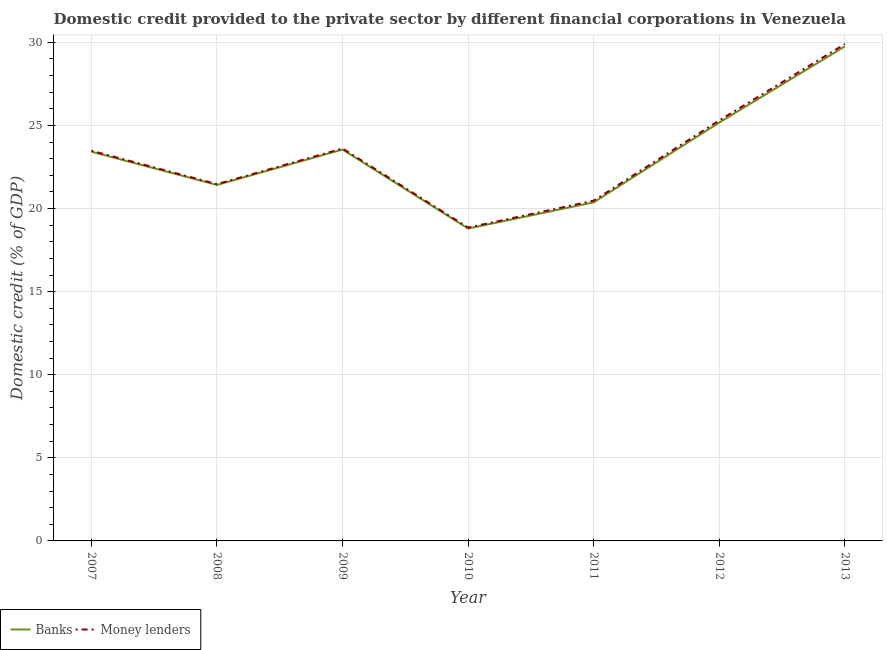Does the line corresponding to domestic credit provided by banks intersect with the line corresponding to domestic credit provided by money lenders?
Offer a very short reply. No. Is the number of lines equal to the number of legend labels?
Provide a short and direct response. Yes. What is the domestic credit provided by money lenders in 2013?
Make the answer very short. 29.9. Across all years, what is the maximum domestic credit provided by banks?
Your answer should be compact. 29.76. Across all years, what is the minimum domestic credit provided by money lenders?
Give a very brief answer. 18.85. In which year was the domestic credit provided by banks minimum?
Provide a short and direct response. 2010. What is the total domestic credit provided by banks in the graph?
Your response must be concise. 162.49. What is the difference between the domestic credit provided by money lenders in 2010 and that in 2012?
Make the answer very short. -6.45. What is the difference between the domestic credit provided by money lenders in 2009 and the domestic credit provided by banks in 2013?
Make the answer very short. -6.14. What is the average domestic credit provided by money lenders per year?
Ensure brevity in your answer.  23.3. In the year 2009, what is the difference between the domestic credit provided by banks and domestic credit provided by money lenders?
Keep it short and to the point. -0.06. What is the ratio of the domestic credit provided by money lenders in 2007 to that in 2012?
Ensure brevity in your answer.  0.93. Is the difference between the domestic credit provided by money lenders in 2011 and 2013 greater than the difference between the domestic credit provided by banks in 2011 and 2013?
Provide a succinct answer. No. What is the difference between the highest and the second highest domestic credit provided by banks?
Ensure brevity in your answer.  4.58. What is the difference between the highest and the lowest domestic credit provided by money lenders?
Ensure brevity in your answer.  11.04. In how many years, is the domestic credit provided by banks greater than the average domestic credit provided by banks taken over all years?
Ensure brevity in your answer.  4. Is the domestic credit provided by banks strictly less than the domestic credit provided by money lenders over the years?
Provide a succinct answer. Yes. What is the difference between two consecutive major ticks on the Y-axis?
Your answer should be very brief. 5. How are the legend labels stacked?
Keep it short and to the point. Horizontal. What is the title of the graph?
Offer a terse response. Domestic credit provided to the private sector by different financial corporations in Venezuela. Does "Forest" appear as one of the legend labels in the graph?
Offer a terse response. No. What is the label or title of the Y-axis?
Offer a very short reply. Domestic credit (% of GDP). What is the Domestic credit (% of GDP) of Banks in 2007?
Your answer should be compact. 23.42. What is the Domestic credit (% of GDP) in Money lenders in 2007?
Keep it short and to the point. 23.48. What is the Domestic credit (% of GDP) in Banks in 2008?
Ensure brevity in your answer.  21.42. What is the Domestic credit (% of GDP) of Money lenders in 2008?
Keep it short and to the point. 21.47. What is the Domestic credit (% of GDP) in Banks in 2009?
Make the answer very short. 23.55. What is the Domestic credit (% of GDP) of Money lenders in 2009?
Keep it short and to the point. 23.61. What is the Domestic credit (% of GDP) in Banks in 2010?
Ensure brevity in your answer.  18.8. What is the Domestic credit (% of GDP) of Money lenders in 2010?
Your answer should be very brief. 18.85. What is the Domestic credit (% of GDP) in Banks in 2011?
Provide a succinct answer. 20.37. What is the Domestic credit (% of GDP) in Money lenders in 2011?
Provide a succinct answer. 20.47. What is the Domestic credit (% of GDP) of Banks in 2012?
Offer a terse response. 25.18. What is the Domestic credit (% of GDP) in Money lenders in 2012?
Give a very brief answer. 25.3. What is the Domestic credit (% of GDP) of Banks in 2013?
Provide a succinct answer. 29.76. What is the Domestic credit (% of GDP) of Money lenders in 2013?
Keep it short and to the point. 29.9. Across all years, what is the maximum Domestic credit (% of GDP) of Banks?
Ensure brevity in your answer.  29.76. Across all years, what is the maximum Domestic credit (% of GDP) in Money lenders?
Keep it short and to the point. 29.9. Across all years, what is the minimum Domestic credit (% of GDP) of Banks?
Make the answer very short. 18.8. Across all years, what is the minimum Domestic credit (% of GDP) in Money lenders?
Provide a short and direct response. 18.85. What is the total Domestic credit (% of GDP) in Banks in the graph?
Offer a terse response. 162.49. What is the total Domestic credit (% of GDP) of Money lenders in the graph?
Provide a succinct answer. 163.09. What is the difference between the Domestic credit (% of GDP) in Banks in 2007 and that in 2008?
Make the answer very short. 2. What is the difference between the Domestic credit (% of GDP) of Money lenders in 2007 and that in 2008?
Your answer should be compact. 2.01. What is the difference between the Domestic credit (% of GDP) of Banks in 2007 and that in 2009?
Offer a terse response. -0.13. What is the difference between the Domestic credit (% of GDP) in Money lenders in 2007 and that in 2009?
Offer a terse response. -0.13. What is the difference between the Domestic credit (% of GDP) of Banks in 2007 and that in 2010?
Provide a short and direct response. 4.62. What is the difference between the Domestic credit (% of GDP) of Money lenders in 2007 and that in 2010?
Make the answer very short. 4.63. What is the difference between the Domestic credit (% of GDP) in Banks in 2007 and that in 2011?
Your answer should be compact. 3.05. What is the difference between the Domestic credit (% of GDP) of Money lenders in 2007 and that in 2011?
Keep it short and to the point. 3.01. What is the difference between the Domestic credit (% of GDP) in Banks in 2007 and that in 2012?
Offer a terse response. -1.76. What is the difference between the Domestic credit (% of GDP) of Money lenders in 2007 and that in 2012?
Provide a short and direct response. -1.82. What is the difference between the Domestic credit (% of GDP) of Banks in 2007 and that in 2013?
Keep it short and to the point. -6.34. What is the difference between the Domestic credit (% of GDP) in Money lenders in 2007 and that in 2013?
Provide a succinct answer. -6.42. What is the difference between the Domestic credit (% of GDP) in Banks in 2008 and that in 2009?
Offer a very short reply. -2.13. What is the difference between the Domestic credit (% of GDP) of Money lenders in 2008 and that in 2009?
Offer a very short reply. -2.14. What is the difference between the Domestic credit (% of GDP) of Banks in 2008 and that in 2010?
Give a very brief answer. 2.62. What is the difference between the Domestic credit (% of GDP) in Money lenders in 2008 and that in 2010?
Give a very brief answer. 2.62. What is the difference between the Domestic credit (% of GDP) in Banks in 2008 and that in 2011?
Provide a succinct answer. 1.05. What is the difference between the Domestic credit (% of GDP) in Money lenders in 2008 and that in 2011?
Keep it short and to the point. 1. What is the difference between the Domestic credit (% of GDP) in Banks in 2008 and that in 2012?
Your answer should be very brief. -3.75. What is the difference between the Domestic credit (% of GDP) of Money lenders in 2008 and that in 2012?
Make the answer very short. -3.83. What is the difference between the Domestic credit (% of GDP) of Banks in 2008 and that in 2013?
Give a very brief answer. -8.33. What is the difference between the Domestic credit (% of GDP) of Money lenders in 2008 and that in 2013?
Offer a terse response. -8.43. What is the difference between the Domestic credit (% of GDP) in Banks in 2009 and that in 2010?
Your answer should be compact. 4.75. What is the difference between the Domestic credit (% of GDP) of Money lenders in 2009 and that in 2010?
Give a very brief answer. 4.76. What is the difference between the Domestic credit (% of GDP) in Banks in 2009 and that in 2011?
Offer a terse response. 3.18. What is the difference between the Domestic credit (% of GDP) of Money lenders in 2009 and that in 2011?
Make the answer very short. 3.14. What is the difference between the Domestic credit (% of GDP) of Banks in 2009 and that in 2012?
Keep it short and to the point. -1.62. What is the difference between the Domestic credit (% of GDP) in Money lenders in 2009 and that in 2012?
Make the answer very short. -1.69. What is the difference between the Domestic credit (% of GDP) of Banks in 2009 and that in 2013?
Provide a short and direct response. -6.21. What is the difference between the Domestic credit (% of GDP) of Money lenders in 2009 and that in 2013?
Offer a very short reply. -6.28. What is the difference between the Domestic credit (% of GDP) of Banks in 2010 and that in 2011?
Offer a very short reply. -1.58. What is the difference between the Domestic credit (% of GDP) of Money lenders in 2010 and that in 2011?
Give a very brief answer. -1.62. What is the difference between the Domestic credit (% of GDP) in Banks in 2010 and that in 2012?
Ensure brevity in your answer.  -6.38. What is the difference between the Domestic credit (% of GDP) of Money lenders in 2010 and that in 2012?
Your answer should be compact. -6.45. What is the difference between the Domestic credit (% of GDP) of Banks in 2010 and that in 2013?
Give a very brief answer. -10.96. What is the difference between the Domestic credit (% of GDP) of Money lenders in 2010 and that in 2013?
Provide a short and direct response. -11.04. What is the difference between the Domestic credit (% of GDP) of Banks in 2011 and that in 2012?
Provide a short and direct response. -4.8. What is the difference between the Domestic credit (% of GDP) of Money lenders in 2011 and that in 2012?
Make the answer very short. -4.83. What is the difference between the Domestic credit (% of GDP) in Banks in 2011 and that in 2013?
Ensure brevity in your answer.  -9.38. What is the difference between the Domestic credit (% of GDP) of Money lenders in 2011 and that in 2013?
Your response must be concise. -9.42. What is the difference between the Domestic credit (% of GDP) in Banks in 2012 and that in 2013?
Offer a terse response. -4.58. What is the difference between the Domestic credit (% of GDP) of Money lenders in 2012 and that in 2013?
Ensure brevity in your answer.  -4.59. What is the difference between the Domestic credit (% of GDP) in Banks in 2007 and the Domestic credit (% of GDP) in Money lenders in 2008?
Keep it short and to the point. 1.95. What is the difference between the Domestic credit (% of GDP) of Banks in 2007 and the Domestic credit (% of GDP) of Money lenders in 2009?
Give a very brief answer. -0.19. What is the difference between the Domestic credit (% of GDP) of Banks in 2007 and the Domestic credit (% of GDP) of Money lenders in 2010?
Your answer should be compact. 4.57. What is the difference between the Domestic credit (% of GDP) of Banks in 2007 and the Domestic credit (% of GDP) of Money lenders in 2011?
Your answer should be very brief. 2.95. What is the difference between the Domestic credit (% of GDP) of Banks in 2007 and the Domestic credit (% of GDP) of Money lenders in 2012?
Your response must be concise. -1.88. What is the difference between the Domestic credit (% of GDP) in Banks in 2007 and the Domestic credit (% of GDP) in Money lenders in 2013?
Keep it short and to the point. -6.48. What is the difference between the Domestic credit (% of GDP) of Banks in 2008 and the Domestic credit (% of GDP) of Money lenders in 2009?
Ensure brevity in your answer.  -2.19. What is the difference between the Domestic credit (% of GDP) of Banks in 2008 and the Domestic credit (% of GDP) of Money lenders in 2010?
Make the answer very short. 2.57. What is the difference between the Domestic credit (% of GDP) of Banks in 2008 and the Domestic credit (% of GDP) of Money lenders in 2011?
Your response must be concise. 0.95. What is the difference between the Domestic credit (% of GDP) of Banks in 2008 and the Domestic credit (% of GDP) of Money lenders in 2012?
Your response must be concise. -3.88. What is the difference between the Domestic credit (% of GDP) in Banks in 2008 and the Domestic credit (% of GDP) in Money lenders in 2013?
Keep it short and to the point. -8.47. What is the difference between the Domestic credit (% of GDP) in Banks in 2009 and the Domestic credit (% of GDP) in Money lenders in 2010?
Keep it short and to the point. 4.7. What is the difference between the Domestic credit (% of GDP) in Banks in 2009 and the Domestic credit (% of GDP) in Money lenders in 2011?
Keep it short and to the point. 3.08. What is the difference between the Domestic credit (% of GDP) in Banks in 2009 and the Domestic credit (% of GDP) in Money lenders in 2012?
Your answer should be very brief. -1.75. What is the difference between the Domestic credit (% of GDP) of Banks in 2009 and the Domestic credit (% of GDP) of Money lenders in 2013?
Your answer should be very brief. -6.35. What is the difference between the Domestic credit (% of GDP) in Banks in 2010 and the Domestic credit (% of GDP) in Money lenders in 2011?
Provide a short and direct response. -1.68. What is the difference between the Domestic credit (% of GDP) in Banks in 2010 and the Domestic credit (% of GDP) in Money lenders in 2012?
Make the answer very short. -6.51. What is the difference between the Domestic credit (% of GDP) of Banks in 2010 and the Domestic credit (% of GDP) of Money lenders in 2013?
Provide a short and direct response. -11.1. What is the difference between the Domestic credit (% of GDP) in Banks in 2011 and the Domestic credit (% of GDP) in Money lenders in 2012?
Your response must be concise. -4.93. What is the difference between the Domestic credit (% of GDP) in Banks in 2011 and the Domestic credit (% of GDP) in Money lenders in 2013?
Your answer should be very brief. -9.52. What is the difference between the Domestic credit (% of GDP) of Banks in 2012 and the Domestic credit (% of GDP) of Money lenders in 2013?
Ensure brevity in your answer.  -4.72. What is the average Domestic credit (% of GDP) in Banks per year?
Your response must be concise. 23.21. What is the average Domestic credit (% of GDP) of Money lenders per year?
Give a very brief answer. 23.3. In the year 2007, what is the difference between the Domestic credit (% of GDP) of Banks and Domestic credit (% of GDP) of Money lenders?
Offer a very short reply. -0.06. In the year 2008, what is the difference between the Domestic credit (% of GDP) of Banks and Domestic credit (% of GDP) of Money lenders?
Provide a succinct answer. -0.05. In the year 2009, what is the difference between the Domestic credit (% of GDP) of Banks and Domestic credit (% of GDP) of Money lenders?
Ensure brevity in your answer.  -0.06. In the year 2010, what is the difference between the Domestic credit (% of GDP) of Banks and Domestic credit (% of GDP) of Money lenders?
Your answer should be compact. -0.06. In the year 2011, what is the difference between the Domestic credit (% of GDP) in Banks and Domestic credit (% of GDP) in Money lenders?
Your answer should be compact. -0.1. In the year 2012, what is the difference between the Domestic credit (% of GDP) of Banks and Domestic credit (% of GDP) of Money lenders?
Offer a very short reply. -0.13. In the year 2013, what is the difference between the Domestic credit (% of GDP) in Banks and Domestic credit (% of GDP) in Money lenders?
Your answer should be very brief. -0.14. What is the ratio of the Domestic credit (% of GDP) in Banks in 2007 to that in 2008?
Your answer should be compact. 1.09. What is the ratio of the Domestic credit (% of GDP) of Money lenders in 2007 to that in 2008?
Make the answer very short. 1.09. What is the ratio of the Domestic credit (% of GDP) of Banks in 2007 to that in 2010?
Your answer should be compact. 1.25. What is the ratio of the Domestic credit (% of GDP) of Money lenders in 2007 to that in 2010?
Offer a very short reply. 1.25. What is the ratio of the Domestic credit (% of GDP) in Banks in 2007 to that in 2011?
Make the answer very short. 1.15. What is the ratio of the Domestic credit (% of GDP) in Money lenders in 2007 to that in 2011?
Your answer should be compact. 1.15. What is the ratio of the Domestic credit (% of GDP) in Banks in 2007 to that in 2012?
Give a very brief answer. 0.93. What is the ratio of the Domestic credit (% of GDP) of Money lenders in 2007 to that in 2012?
Provide a succinct answer. 0.93. What is the ratio of the Domestic credit (% of GDP) of Banks in 2007 to that in 2013?
Provide a succinct answer. 0.79. What is the ratio of the Domestic credit (% of GDP) of Money lenders in 2007 to that in 2013?
Offer a terse response. 0.79. What is the ratio of the Domestic credit (% of GDP) of Banks in 2008 to that in 2009?
Provide a short and direct response. 0.91. What is the ratio of the Domestic credit (% of GDP) in Money lenders in 2008 to that in 2009?
Ensure brevity in your answer.  0.91. What is the ratio of the Domestic credit (% of GDP) of Banks in 2008 to that in 2010?
Offer a terse response. 1.14. What is the ratio of the Domestic credit (% of GDP) of Money lenders in 2008 to that in 2010?
Your answer should be very brief. 1.14. What is the ratio of the Domestic credit (% of GDP) in Banks in 2008 to that in 2011?
Make the answer very short. 1.05. What is the ratio of the Domestic credit (% of GDP) in Money lenders in 2008 to that in 2011?
Make the answer very short. 1.05. What is the ratio of the Domestic credit (% of GDP) of Banks in 2008 to that in 2012?
Ensure brevity in your answer.  0.85. What is the ratio of the Domestic credit (% of GDP) of Money lenders in 2008 to that in 2012?
Your response must be concise. 0.85. What is the ratio of the Domestic credit (% of GDP) of Banks in 2008 to that in 2013?
Provide a succinct answer. 0.72. What is the ratio of the Domestic credit (% of GDP) of Money lenders in 2008 to that in 2013?
Your answer should be compact. 0.72. What is the ratio of the Domestic credit (% of GDP) of Banks in 2009 to that in 2010?
Offer a terse response. 1.25. What is the ratio of the Domestic credit (% of GDP) of Money lenders in 2009 to that in 2010?
Offer a terse response. 1.25. What is the ratio of the Domestic credit (% of GDP) in Banks in 2009 to that in 2011?
Keep it short and to the point. 1.16. What is the ratio of the Domestic credit (% of GDP) in Money lenders in 2009 to that in 2011?
Provide a succinct answer. 1.15. What is the ratio of the Domestic credit (% of GDP) of Banks in 2009 to that in 2012?
Your response must be concise. 0.94. What is the ratio of the Domestic credit (% of GDP) in Money lenders in 2009 to that in 2012?
Your response must be concise. 0.93. What is the ratio of the Domestic credit (% of GDP) of Banks in 2009 to that in 2013?
Make the answer very short. 0.79. What is the ratio of the Domestic credit (% of GDP) of Money lenders in 2009 to that in 2013?
Provide a succinct answer. 0.79. What is the ratio of the Domestic credit (% of GDP) of Banks in 2010 to that in 2011?
Your answer should be very brief. 0.92. What is the ratio of the Domestic credit (% of GDP) in Money lenders in 2010 to that in 2011?
Give a very brief answer. 0.92. What is the ratio of the Domestic credit (% of GDP) of Banks in 2010 to that in 2012?
Your response must be concise. 0.75. What is the ratio of the Domestic credit (% of GDP) in Money lenders in 2010 to that in 2012?
Make the answer very short. 0.75. What is the ratio of the Domestic credit (% of GDP) of Banks in 2010 to that in 2013?
Offer a very short reply. 0.63. What is the ratio of the Domestic credit (% of GDP) in Money lenders in 2010 to that in 2013?
Give a very brief answer. 0.63. What is the ratio of the Domestic credit (% of GDP) of Banks in 2011 to that in 2012?
Make the answer very short. 0.81. What is the ratio of the Domestic credit (% of GDP) in Money lenders in 2011 to that in 2012?
Your answer should be compact. 0.81. What is the ratio of the Domestic credit (% of GDP) of Banks in 2011 to that in 2013?
Provide a short and direct response. 0.68. What is the ratio of the Domestic credit (% of GDP) in Money lenders in 2011 to that in 2013?
Give a very brief answer. 0.68. What is the ratio of the Domestic credit (% of GDP) of Banks in 2012 to that in 2013?
Ensure brevity in your answer.  0.85. What is the ratio of the Domestic credit (% of GDP) in Money lenders in 2012 to that in 2013?
Give a very brief answer. 0.85. What is the difference between the highest and the second highest Domestic credit (% of GDP) in Banks?
Provide a short and direct response. 4.58. What is the difference between the highest and the second highest Domestic credit (% of GDP) in Money lenders?
Keep it short and to the point. 4.59. What is the difference between the highest and the lowest Domestic credit (% of GDP) in Banks?
Offer a very short reply. 10.96. What is the difference between the highest and the lowest Domestic credit (% of GDP) of Money lenders?
Make the answer very short. 11.04. 